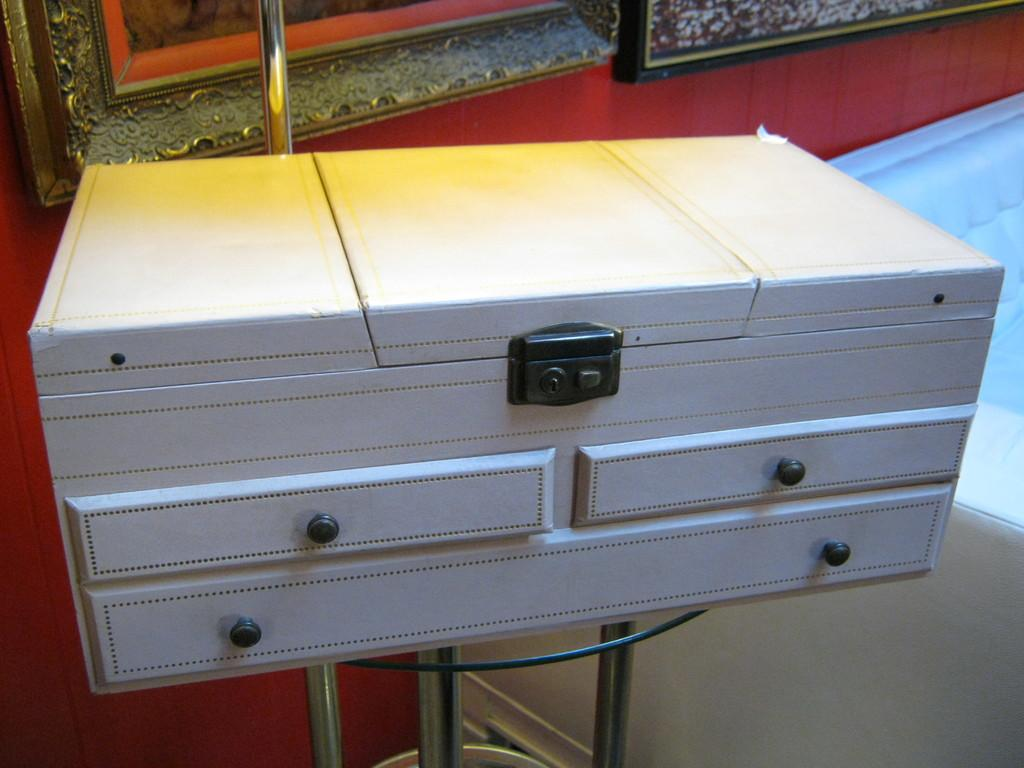What type of furniture is located in the middle of the picture? There are white color chests of drawers in the middle of the picture. Where are the chests of drawers situated? The chests of drawers are inside a room. What color is the wall behind the chests of drawers? There is a red color wall behind the chests of drawers. Can you describe the window visible in the image? There is a window visible in the image, but no specific details about the window are provided in the facts. What type of current is flowing through the baby's country in the image? There is no baby or country present in the image, so it is not possible to answer that question. 